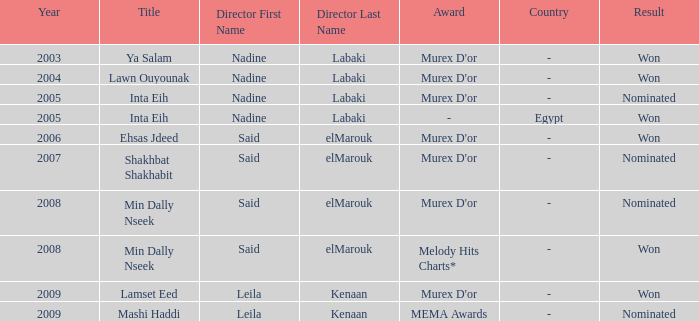What is the title for the Murex D'or survey, after 2005, Said Elmarouk as director, and was nominated? Shakhbat Shakhabit, Min Dally Nseek. 